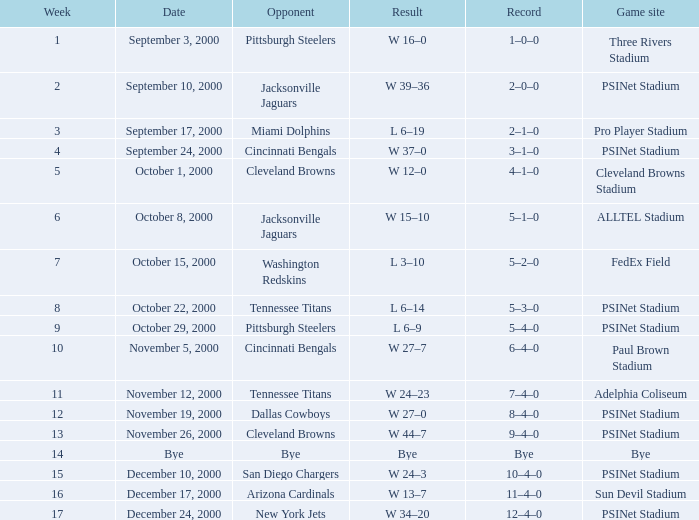What is the standing after the 12th week when a bye game occurs? Bye. 